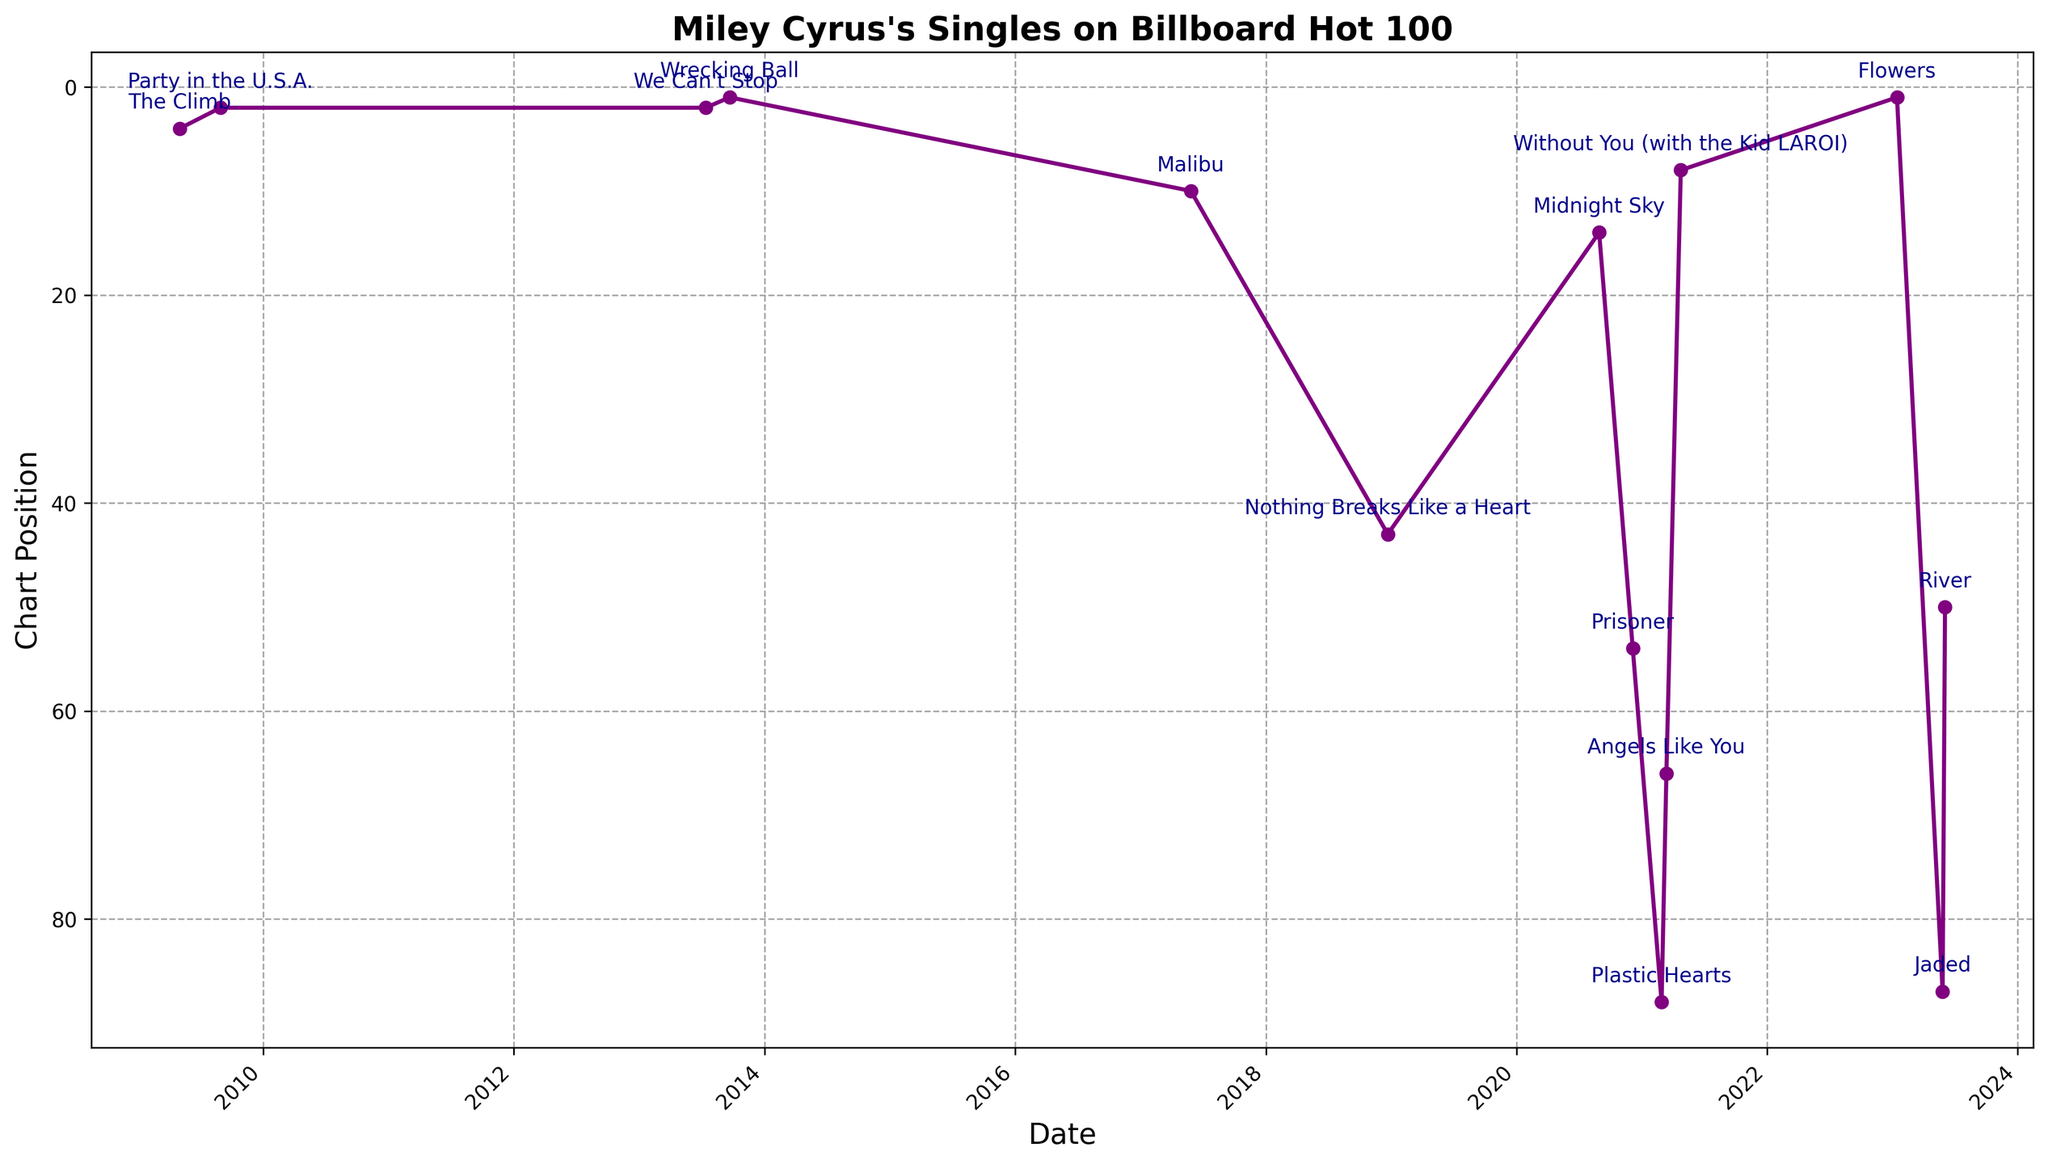What's the highest chart position achieved by Miley Cyrus? Look for the lowest point on the y-axis (since the chart position scale is reversed) where the line reaches position 1 to indicate the highest chart position. "Wrecking Ball" and "Flowers" both hit position 1.
Answer: 1 Which single stayed in the top 10 the longest duration? Examine the data points for each single's placement in the top 10 section of the y-axis. "Party in the U.S.A." and "We Can't Stop" also stayed in the top 10 but "Wrecking Ball" appears multiple times in the top 10 positions.
Answer: Wrecking Ball What was the chart position of "Malibu" upon its release? Look for the data point corresponding to the release date of "Malibu" and check its y-axis value. "Malibu" was released on 2017-05-27 and reached position 10.
Answer: 10 How many singles have reached the top 5 chart positions? Count the number of singles whose data points fall between positions 1 to 5 on the y-axis. "Party in the U.S.A.", "The Climb", "Wrecking Ball", and "We Can't Stop" are in the top 5 positions.
Answer: 4 Which single had the greatest drop in chart position from its peak? Look for the single with the largest difference between its highest point on the y-axis (lowest numerical chart position) and its lowest point on the y-axis (highest numerical chart position). "Wrecking Ball" dropped from 1 to somewhere below 10 rapidly.
Answer: Wrecking Ball What is the average peak position of singles released after 2020? Identify singles released after 2020, find their peak positions, sum these positions, and divide by the number of singles. Singles are "Midnight Sky" (14), "Prisoner" (54), "Angels Like You" (66), "Without You" (8), "Plastic Hearts" (88), "Flowers" (1), "Jaded" (87), "River" (50). Average = (14+54+66+8+88+1+87+50)/8 = 46
Answer: 46 Which two singles have similar peak positions but were released in different years? Compare the peak positions and release dates of singles, looking for two with the same or nearly same chart positions but different years. "Midnight Sky" (2020, 14) and "Malibu" (2017, 10) are quite close.
Answer: Midnight Sky and Malibu Is there any observable trend in the chart positions of Miley Cyrus's singles over the years? Look for a general pattern in the line chart, noting whether the positions are improving, worsening, or fluctuating. Since "Wrecking Ball" hit #1 in 2013 and again "Flowers" in 2023, there's a general fluctuation with some top hits interspersed over time.
Answer: Fluctuating How many singles released in 2023 to date are in the top 50? Check the singles released in 2023 and their respective positions, identifying those in the top 50. "Flowers" (1) and "River" (50) are in the top 50 out of the 3 singles released.
Answer: 2 